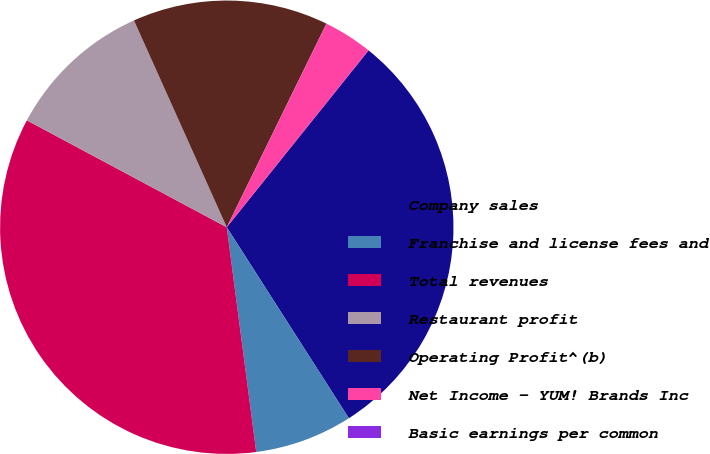Convert chart to OTSL. <chart><loc_0><loc_0><loc_500><loc_500><pie_chart><fcel>Company sales<fcel>Franchise and license fees and<fcel>Total revenues<fcel>Restaurant profit<fcel>Operating Profit^(b)<fcel>Net Income - YUM! Brands Inc<fcel>Basic earnings per common<nl><fcel>30.19%<fcel>6.98%<fcel>34.89%<fcel>10.47%<fcel>13.96%<fcel>3.5%<fcel>0.01%<nl></chart> 